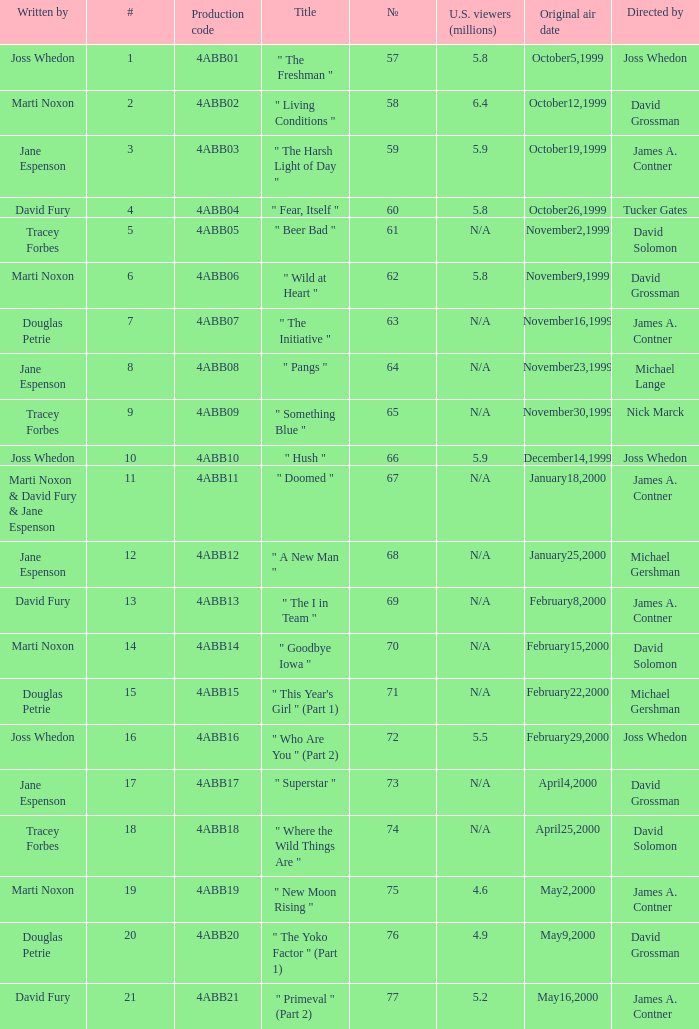What is the series No when the season 4 # is 18? 74.0. 